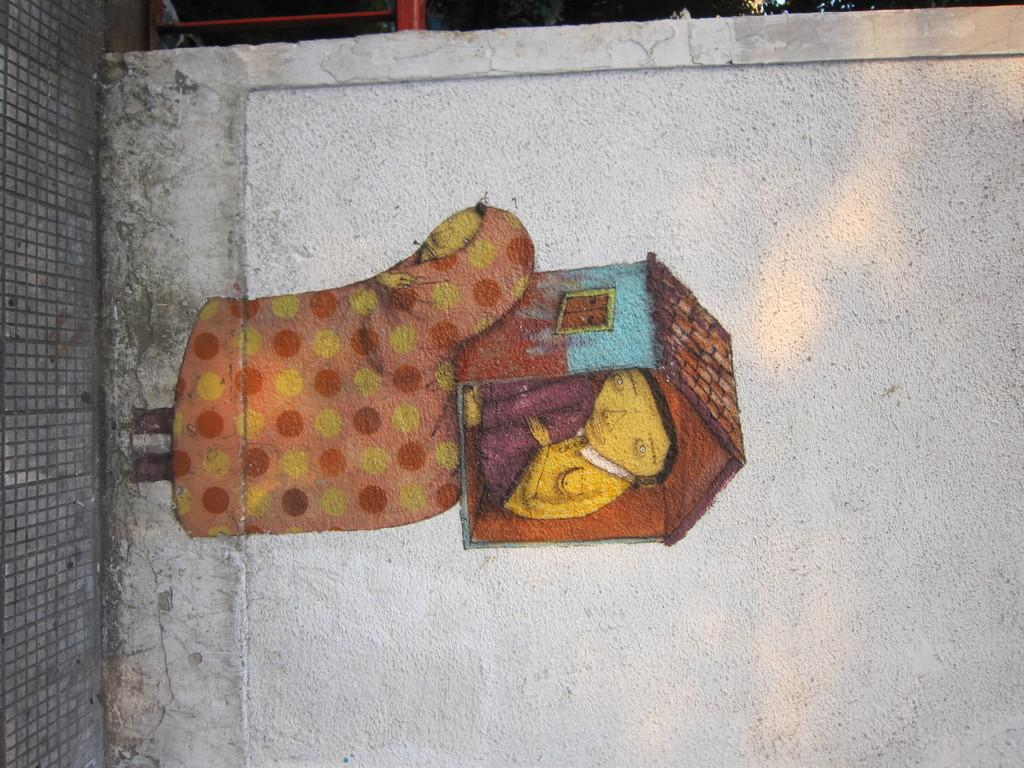What is present on the wall in the image? There is a painting on the wall in the image. What is the setting of the image? The image depicts a street. What type of snow can be seen falling in the image? There is no snow present in the image; it depicts a street with a painting on a wall. What is the title of the painting in the image? The provided facts do not mention a title for the painting, so we cannot determine its title from the image. 